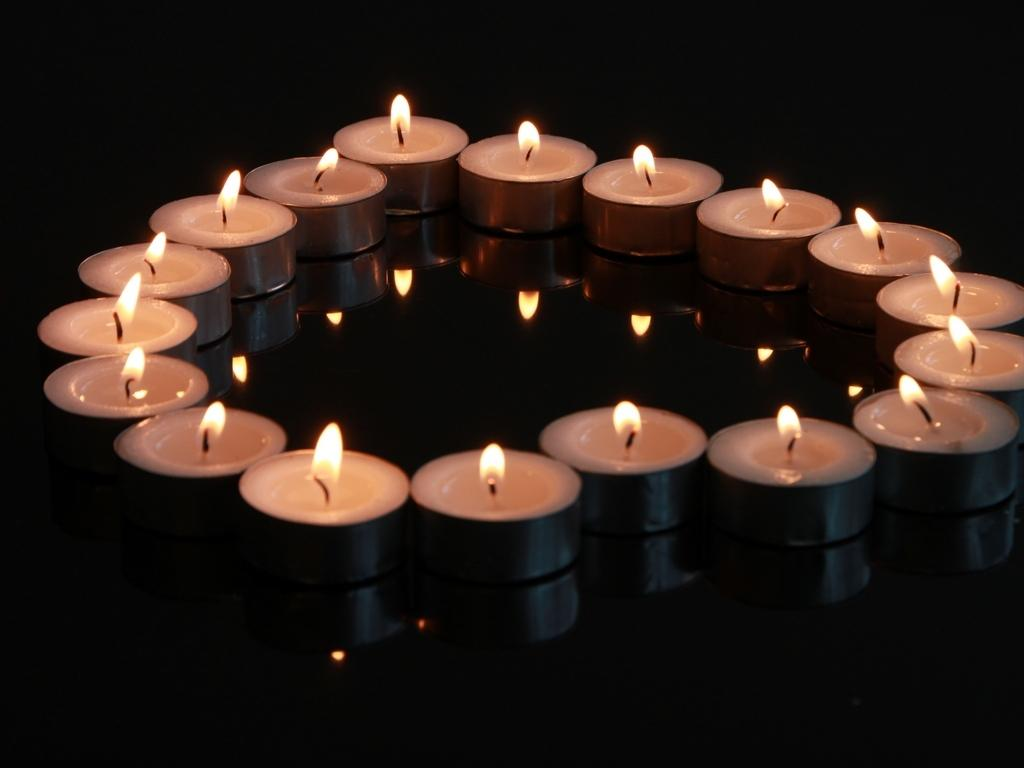What objects can be seen in the image? There are candles in the image. Can you describe any additional features of the candles? Yes, there is a reflection of the candles in the image. How would you describe the overall lighting in the image? The image appears to be slightly dark. Can you see the ocean in the image? No, there is no ocean present in the image. What type of pleasure can be observed in the image? There is no indication of pleasure in the image, as it only features candles and their reflection. 